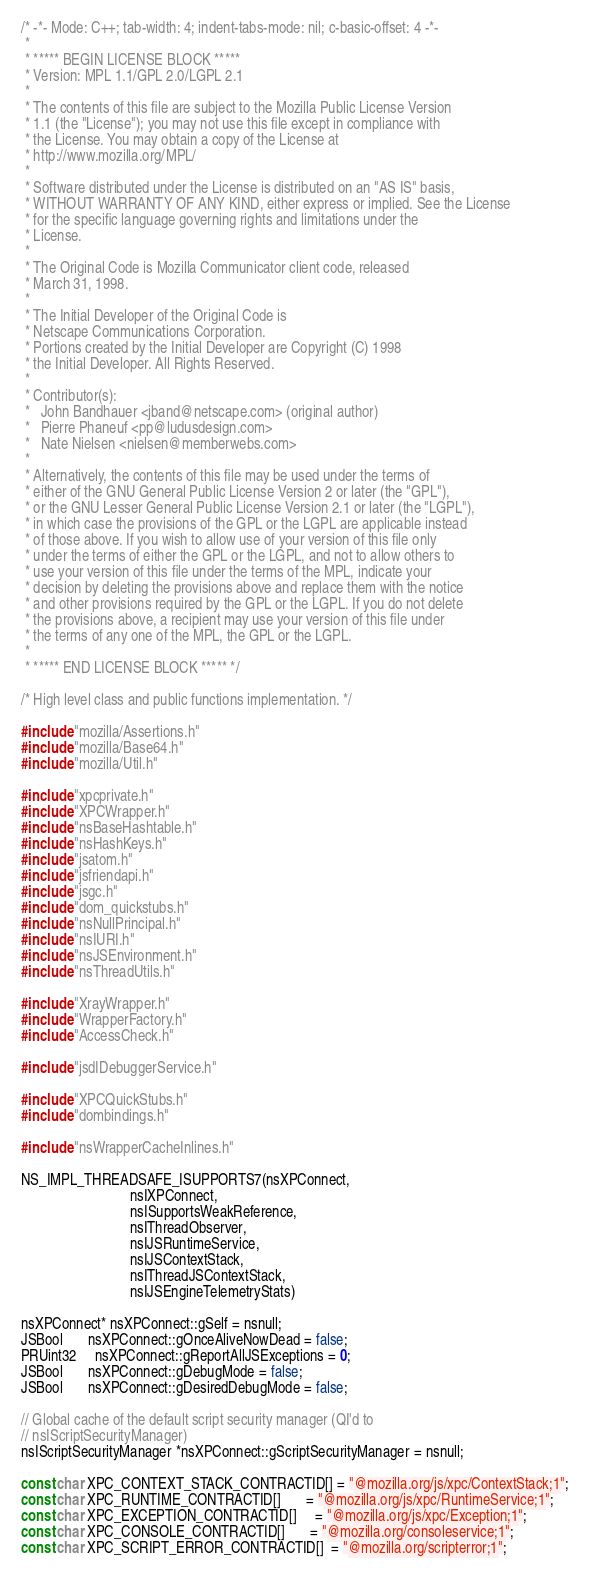Convert code to text. <code><loc_0><loc_0><loc_500><loc_500><_C++_>/* -*- Mode: C++; tab-width: 4; indent-tabs-mode: nil; c-basic-offset: 4 -*-
 *
 * ***** BEGIN LICENSE BLOCK *****
 * Version: MPL 1.1/GPL 2.0/LGPL 2.1
 *
 * The contents of this file are subject to the Mozilla Public License Version
 * 1.1 (the "License"); you may not use this file except in compliance with
 * the License. You may obtain a copy of the License at
 * http://www.mozilla.org/MPL/
 *
 * Software distributed under the License is distributed on an "AS IS" basis,
 * WITHOUT WARRANTY OF ANY KIND, either express or implied. See the License
 * for the specific language governing rights and limitations under the
 * License.
 *
 * The Original Code is Mozilla Communicator client code, released
 * March 31, 1998.
 *
 * The Initial Developer of the Original Code is
 * Netscape Communications Corporation.
 * Portions created by the Initial Developer are Copyright (C) 1998
 * the Initial Developer. All Rights Reserved.
 *
 * Contributor(s):
 *   John Bandhauer <jband@netscape.com> (original author)
 *   Pierre Phaneuf <pp@ludusdesign.com>
 *   Nate Nielsen <nielsen@memberwebs.com>
 *
 * Alternatively, the contents of this file may be used under the terms of
 * either of the GNU General Public License Version 2 or later (the "GPL"),
 * or the GNU Lesser General Public License Version 2.1 or later (the "LGPL"),
 * in which case the provisions of the GPL or the LGPL are applicable instead
 * of those above. If you wish to allow use of your version of this file only
 * under the terms of either the GPL or the LGPL, and not to allow others to
 * use your version of this file under the terms of the MPL, indicate your
 * decision by deleting the provisions above and replace them with the notice
 * and other provisions required by the GPL or the LGPL. If you do not delete
 * the provisions above, a recipient may use your version of this file under
 * the terms of any one of the MPL, the GPL or the LGPL.
 *
 * ***** END LICENSE BLOCK ***** */

/* High level class and public functions implementation. */

#include "mozilla/Assertions.h"
#include "mozilla/Base64.h"
#include "mozilla/Util.h"

#include "xpcprivate.h"
#include "XPCWrapper.h"
#include "nsBaseHashtable.h"
#include "nsHashKeys.h"
#include "jsatom.h"
#include "jsfriendapi.h"
#include "jsgc.h"
#include "dom_quickstubs.h"
#include "nsNullPrincipal.h"
#include "nsIURI.h"
#include "nsJSEnvironment.h"
#include "nsThreadUtils.h"

#include "XrayWrapper.h"
#include "WrapperFactory.h"
#include "AccessCheck.h"

#include "jsdIDebuggerService.h"

#include "XPCQuickStubs.h"
#include "dombindings.h"

#include "nsWrapperCacheInlines.h"

NS_IMPL_THREADSAFE_ISUPPORTS7(nsXPConnect,
                              nsIXPConnect,
                              nsISupportsWeakReference,
                              nsIThreadObserver,
                              nsIJSRuntimeService,
                              nsIJSContextStack,
                              nsIThreadJSContextStack,
                              nsIJSEngineTelemetryStats)

nsXPConnect* nsXPConnect::gSelf = nsnull;
JSBool       nsXPConnect::gOnceAliveNowDead = false;
PRUint32     nsXPConnect::gReportAllJSExceptions = 0;
JSBool       nsXPConnect::gDebugMode = false;
JSBool       nsXPConnect::gDesiredDebugMode = false;

// Global cache of the default script security manager (QI'd to
// nsIScriptSecurityManager)
nsIScriptSecurityManager *nsXPConnect::gScriptSecurityManager = nsnull;

const char XPC_CONTEXT_STACK_CONTRACTID[] = "@mozilla.org/js/xpc/ContextStack;1";
const char XPC_RUNTIME_CONTRACTID[]       = "@mozilla.org/js/xpc/RuntimeService;1";
const char XPC_EXCEPTION_CONTRACTID[]     = "@mozilla.org/js/xpc/Exception;1";
const char XPC_CONSOLE_CONTRACTID[]       = "@mozilla.org/consoleservice;1";
const char XPC_SCRIPT_ERROR_CONTRACTID[]  = "@mozilla.org/scripterror;1";</code> 